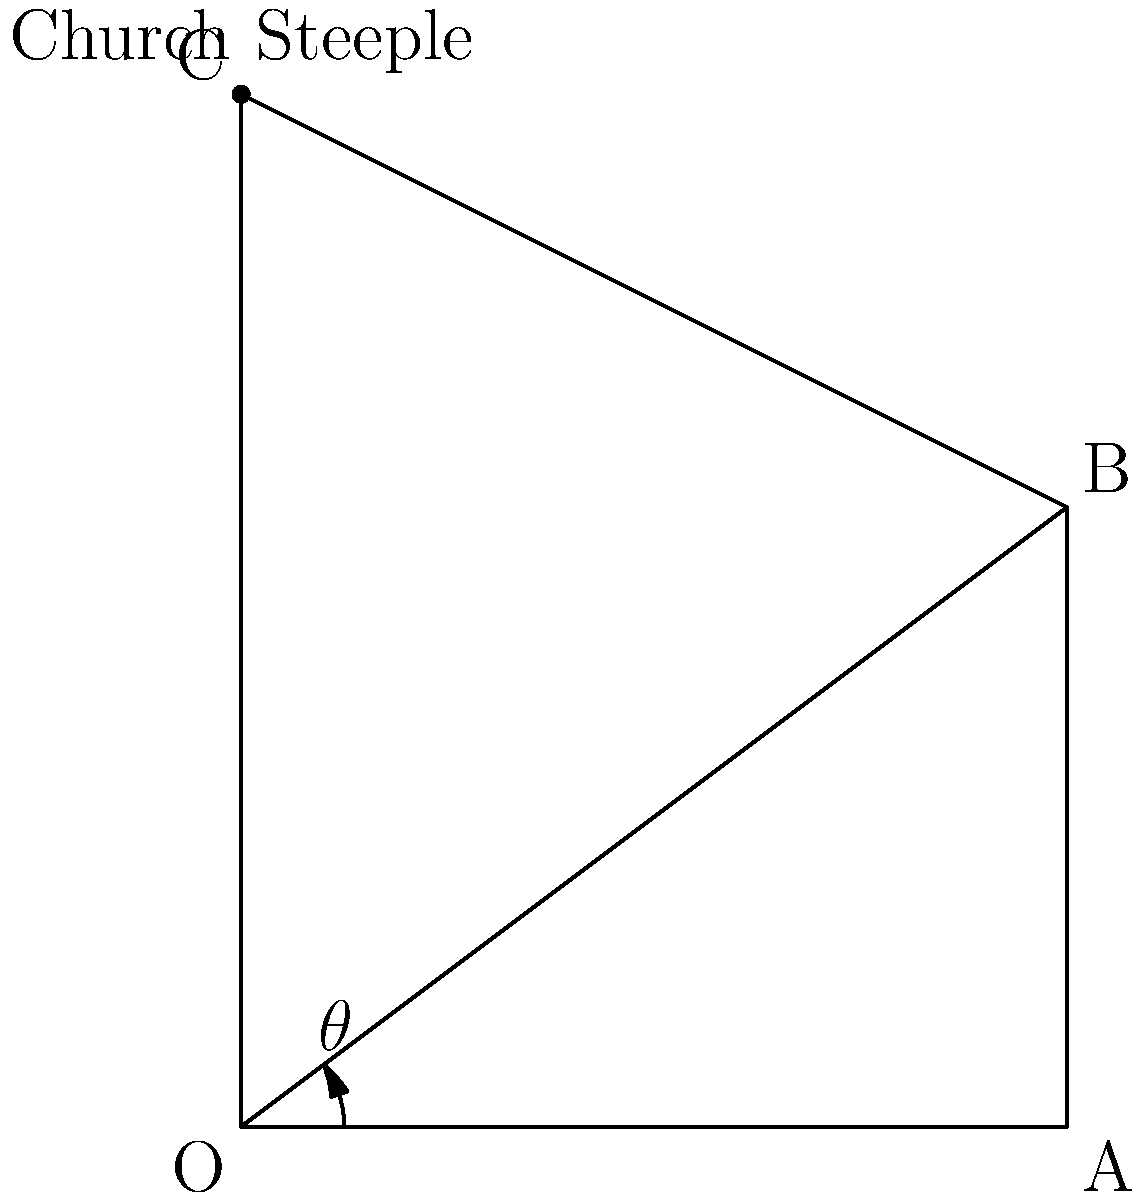Your son, who serves as an altar boy, is curious about the height of the church steeple. To help him understand, you decide to teach him about angles of elevation using polar coordinates. From point A, which is 4 units away from the base of the steeple (point O), the angle of elevation to the top of the steeple (point C) is 51.34°. If you move to point B, which is 3 units closer to the steeple along the same line, what is the new angle of elevation $\theta$ to the top of the steeple? Let's approach this step-by-step:

1) First, we need to identify the known information:
   - The distance OA is 4 units
   - The distance OB is 1 unit (since B is 3 units closer to O than A)
   - The height of the steeple (OC) is 5 units (we can calculate this using the initial angle)

2) Calculate the height of the steeple:
   $\tan(51.34°) = \frac{OC}{OA}$
   $OC = 4 \tan(51.34°) \approx 5$ units

3) Now we can use the arctangent function to find the new angle $\theta$:
   $\theta = \arctan(\frac{OC}{OB})$

4) Substituting the values:
   $\theta = \arctan(\frac{5}{1}) = \arctan(5)$

5) Calculate the result:
   $\theta = \arctan(5) \approx 78.69°$

Therefore, the new angle of elevation from point B is approximately 78.69°.
Answer: $78.69°$ 